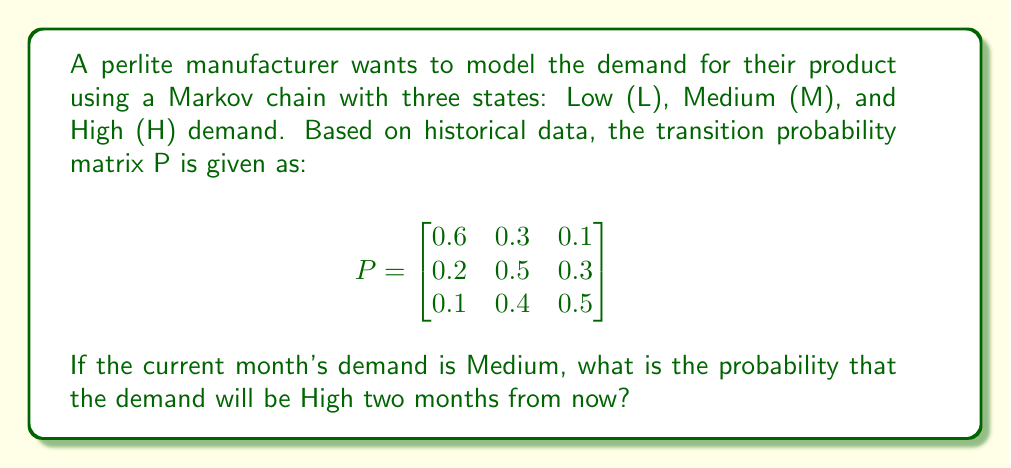Show me your answer to this math problem. To solve this problem, we need to use the Chapman-Kolmogorov equations and calculate the two-step transition probability from Medium to High.

Step 1: Identify the initial state and target state.
Initial state: Medium (M)
Target state: High (H)
Time steps: 2

Step 2: Calculate the two-step transition probability matrix by squaring the given matrix P.
$$P^2 = P \times P = \begin{bmatrix}
0.6 & 0.3 & 0.1 \\
0.2 & 0.5 & 0.3 \\
0.1 & 0.4 & 0.5
\end{bmatrix} \times \begin{bmatrix}
0.6 & 0.3 & 0.1 \\
0.2 & 0.5 & 0.3 \\
0.1 & 0.4 & 0.5
\end{bmatrix}$$

Step 3: Perform matrix multiplication.
$$P^2 = \begin{bmatrix}
0.42 & 0.39 & 0.19 \\
0.25 & 0.46 & 0.29 \\
0.19 & 0.44 & 0.37
\end{bmatrix}$$

Step 4: Identify the probability of transitioning from Medium to High in two steps.
This is the element in the second row (M) and third column (H) of the $P^2$ matrix.

The probability of transitioning from Medium to High in two months is 0.29 or 29%.
Answer: 0.29 